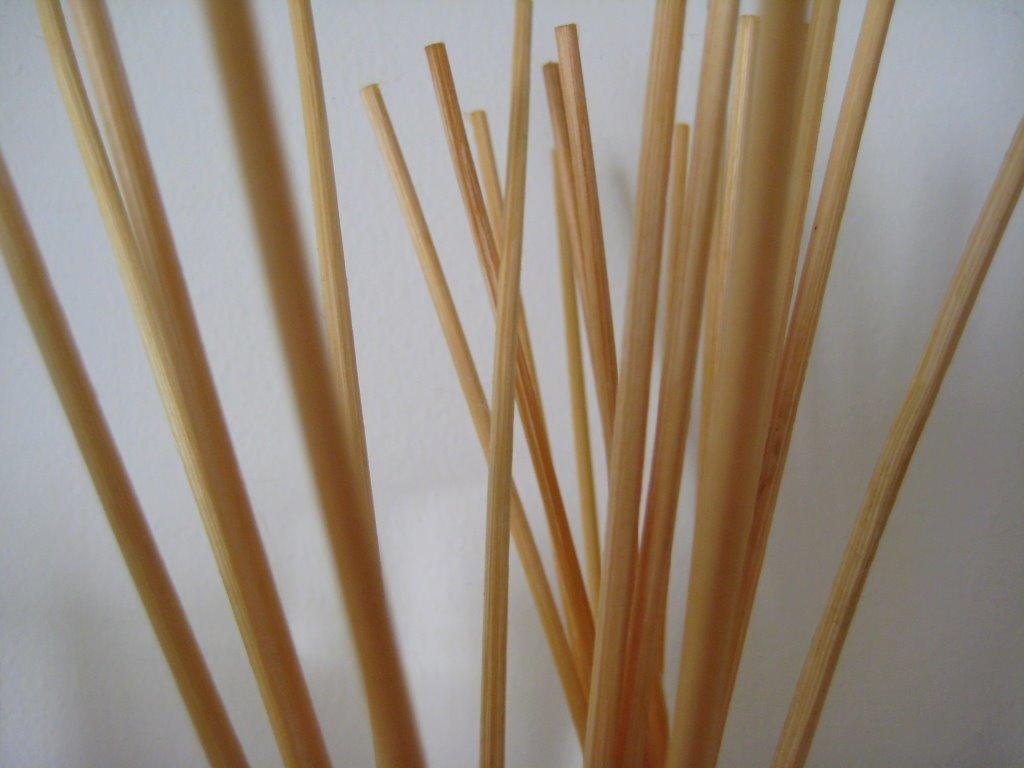What color is the wall that is visible in the image? The wall in the image is white. What objects can be seen in the image besides the wall? There are sticks visible in the image. How many people are in the group that is falling in the image? There is no group of people falling in the image; it only features a white wall and sticks. 